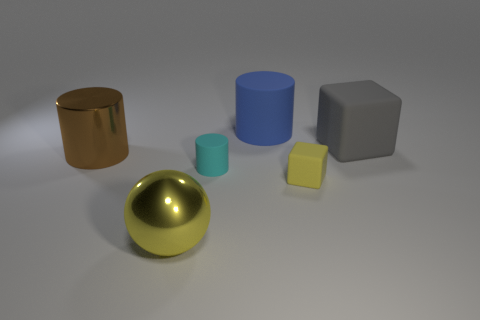Add 1 yellow things. How many objects exist? 7 Subtract all balls. How many objects are left? 5 Add 2 small purple matte things. How many small purple matte things exist? 2 Subtract 0 green cylinders. How many objects are left? 6 Subtract all small blocks. Subtract all yellow metal objects. How many objects are left? 4 Add 6 tiny yellow rubber cubes. How many tiny yellow rubber cubes are left? 7 